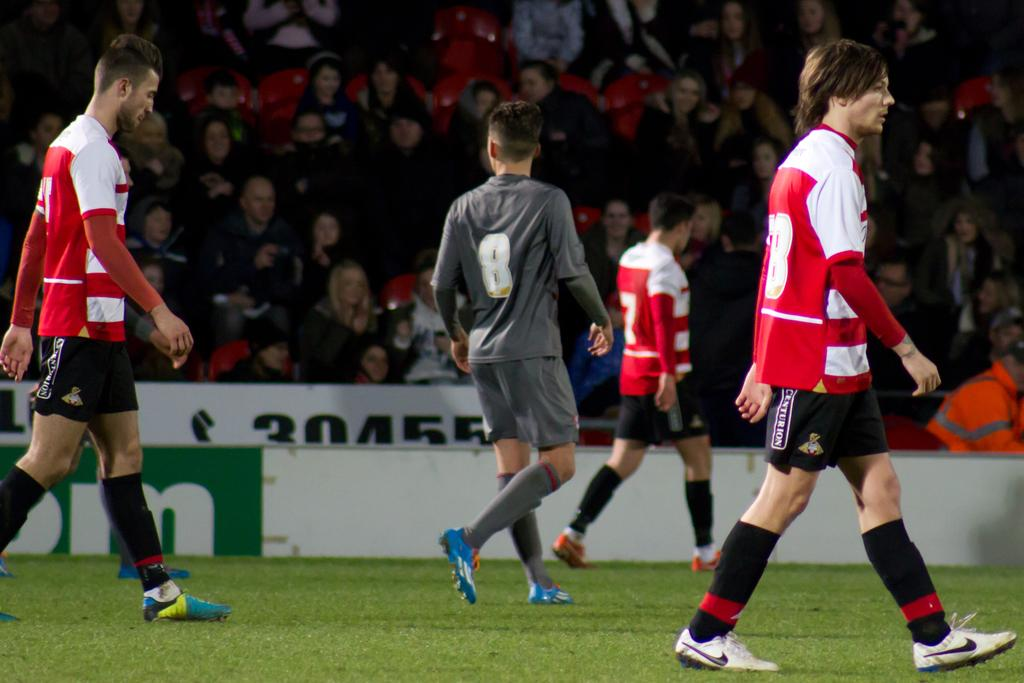How many men are present in the image? There are four men in the image. What are the men doing in the image? The men are walking on the ground. What can be seen in the background of the image? There is an audience and a hoarding in the background of the image. How is the audience positioned in the image? The audience is sitting on chairs. What type of shade is provided by the trees in the image? There are no trees present in the image, so no shade is provided. What kind of popcorn is being sold at the event in the image? There is no mention of popcorn or an event in the image, so it cannot be determined. 